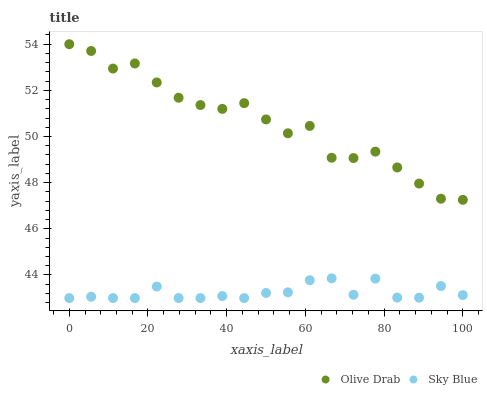Does Sky Blue have the minimum area under the curve?
Answer yes or no. Yes. Does Olive Drab have the maximum area under the curve?
Answer yes or no. Yes. Does Olive Drab have the minimum area under the curve?
Answer yes or no. No. Is Sky Blue the smoothest?
Answer yes or no. Yes. Is Olive Drab the roughest?
Answer yes or no. Yes. Is Olive Drab the smoothest?
Answer yes or no. No. Does Sky Blue have the lowest value?
Answer yes or no. Yes. Does Olive Drab have the lowest value?
Answer yes or no. No. Does Olive Drab have the highest value?
Answer yes or no. Yes. Is Sky Blue less than Olive Drab?
Answer yes or no. Yes. Is Olive Drab greater than Sky Blue?
Answer yes or no. Yes. Does Sky Blue intersect Olive Drab?
Answer yes or no. No. 